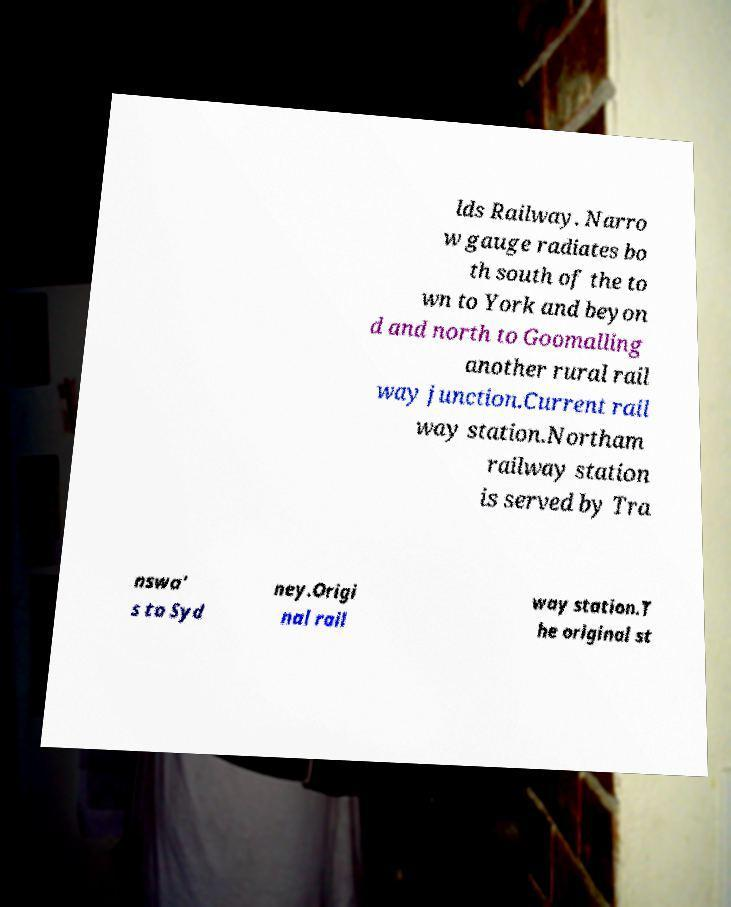What messages or text are displayed in this image? I need them in a readable, typed format. lds Railway. Narro w gauge radiates bo th south of the to wn to York and beyon d and north to Goomalling another rural rail way junction.Current rail way station.Northam railway station is served by Tra nswa' s to Syd ney.Origi nal rail way station.T he original st 